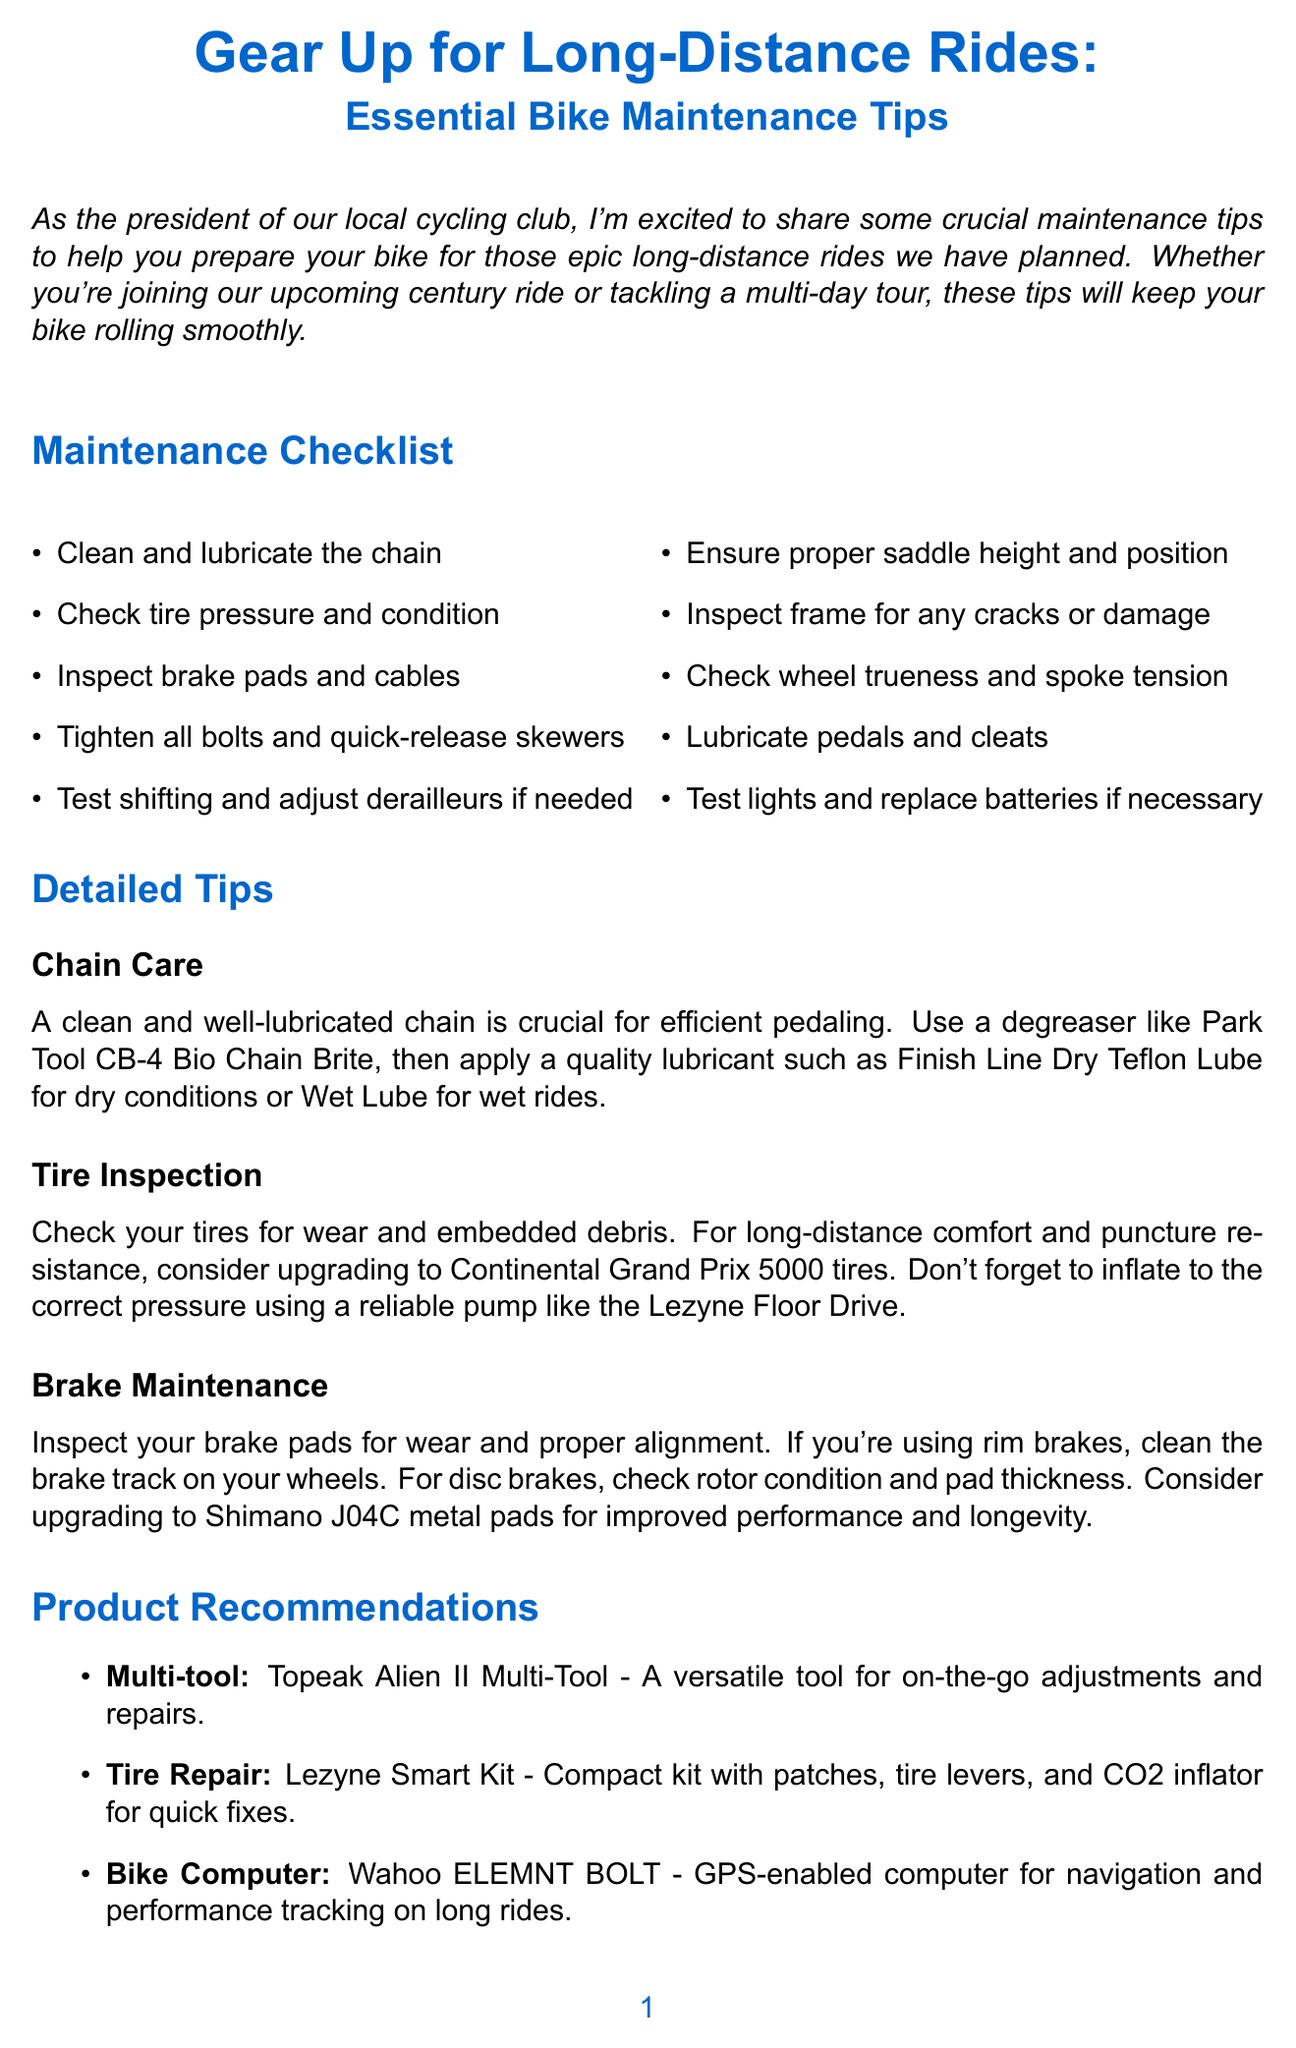what is the title of the newsletter? The title is prominently displayed at the top, which is "Gear Up for Long-Distance Rides: Essential Bike Maintenance Tips."
Answer: Gear Up for Long-Distance Rides: Essential Bike Maintenance Tips how many items are listed in the maintenance checklist? The maintenance checklist contains a total of ten items listed for bike preparation.
Answer: 10 which product is recommended for tire repair? The recommended product for tire repair is specified clearly in the Product Recommendations section.
Answer: Lezyne Smart Kit what is one of the recommended lubricants for the bike chain? The document provides details on suitable lubricants for the bike chain care section.
Answer: Finish Line Dry Teflon Lube what is the purpose of the maintenance workshop mentioned in the conclusion? The workshop aims to provide more in-depth information about bike maintenance in preparation for rides.
Answer: Bike prep who is sharing the maintenance tips in the newsletter? The introduction clearly states the individual responsible for sharing the tips.
Answer: The president of our local cycling club what should you check on your tires before a long-distance ride? The maintenance checklist provides specific instructions for tire condition checks.
Answer: Pressure and condition when does early bird registration for the event close? The specific timeline for early bird registration is mentioned in the call to action.
Answer: In two weeks 